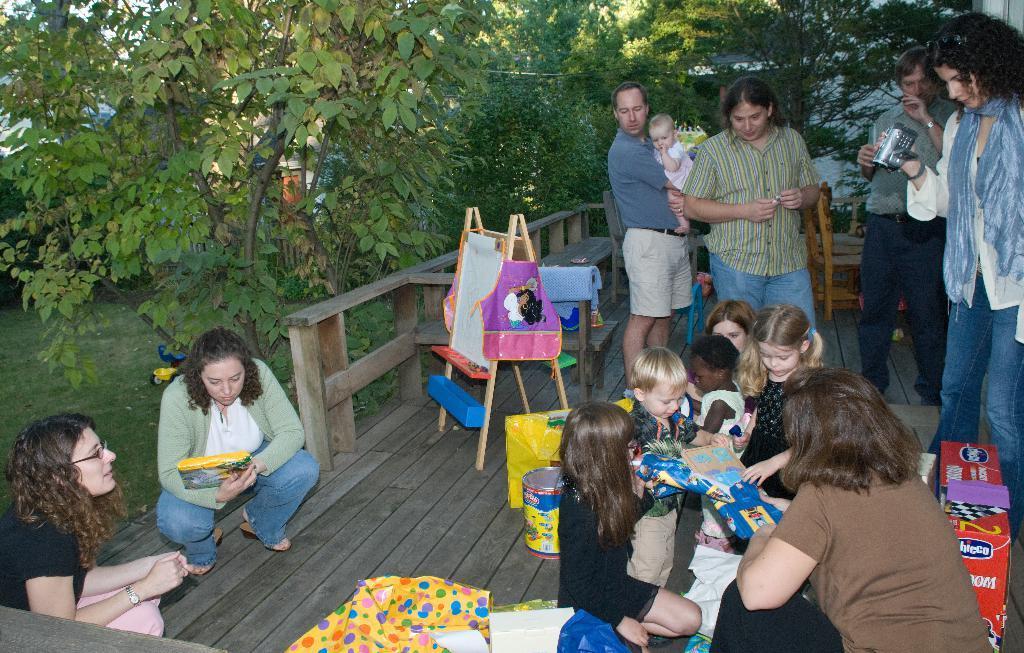How would you summarize this image in a sentence or two? There are group of kids playing the game and around them there are many people, they are watching the kids and one of the woman is taking the video of the kids. The kids are sitting on a wooden floor and beside the wooden floor there are many trees and a garden. 